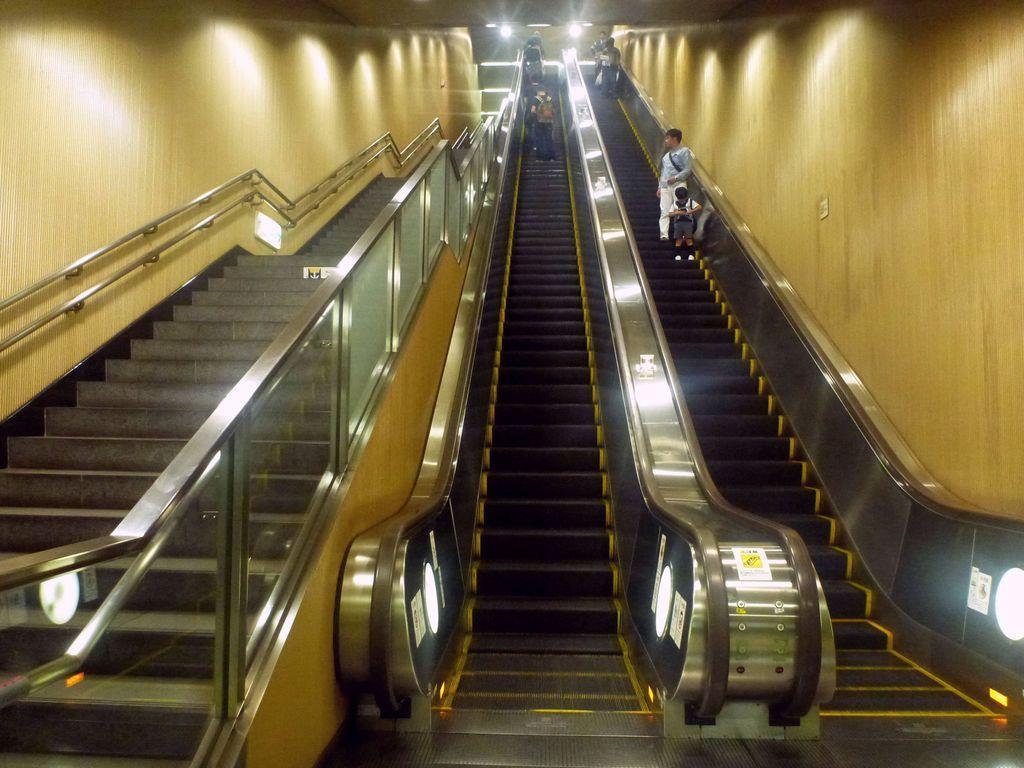Please provide a concise description of this image. This picture was taken from inside. In this picture we can see escalator and people were on the escalator. At the background there are lights. 